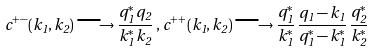<formula> <loc_0><loc_0><loc_500><loc_500>c ^ { + - } ( k _ { 1 } , k _ { 2 } ) \longrightarrow \frac { q _ { 1 } ^ { * } \, q _ { 2 } } { k _ { 1 } ^ { * } \, k _ { 2 } } \, , \, c ^ { + + } ( k _ { 1 } , k _ { 2 } ) \longrightarrow \frac { q _ { 1 } ^ { * } } { k _ { 1 } ^ { * } } \, \frac { q _ { 1 } - k _ { 1 } } { q _ { 1 } ^ { * } - k _ { 1 } ^ { * } } \, \frac { q _ { 2 } ^ { * } } { k _ { 2 } ^ { * } }</formula> 